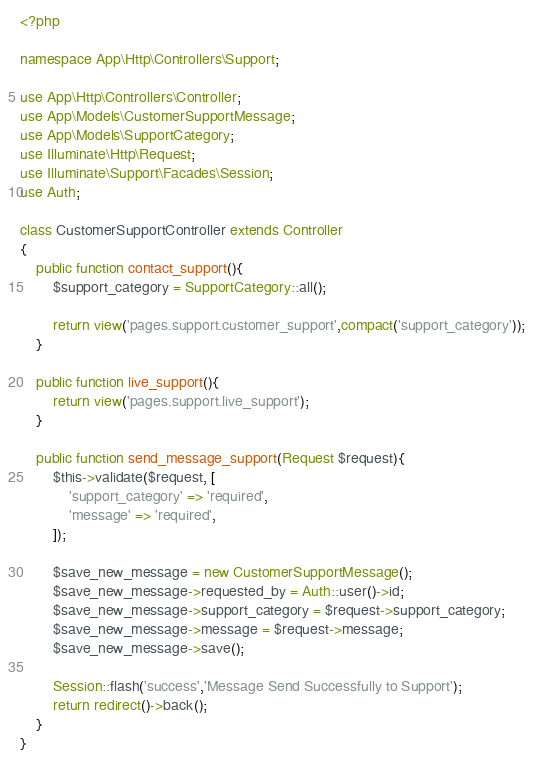Convert code to text. <code><loc_0><loc_0><loc_500><loc_500><_PHP_><?php

namespace App\Http\Controllers\Support;

use App\Http\Controllers\Controller;
use App\Models\CustomerSupportMessage;
use App\Models\SupportCategory;
use Illuminate\Http\Request;
use Illuminate\Support\Facades\Session;
use Auth;

class CustomerSupportController extends Controller
{
    public function contact_support(){
        $support_category = SupportCategory::all();

        return view('pages.support.customer_support',compact('support_category'));
    }

    public function live_support(){
        return view('pages.support.live_support');
    }

    public function send_message_support(Request $request){
        $this->validate($request, [
            'support_category' => 'required',
            'message' => 'required',
        ]);

        $save_new_message = new CustomerSupportMessage();
        $save_new_message->requested_by = Auth::user()->id;
        $save_new_message->support_category = $request->support_category;
        $save_new_message->message = $request->message;
        $save_new_message->save();

        Session::flash('success','Message Send Successfully to Support');
        return redirect()->back();
    }
}
</code> 